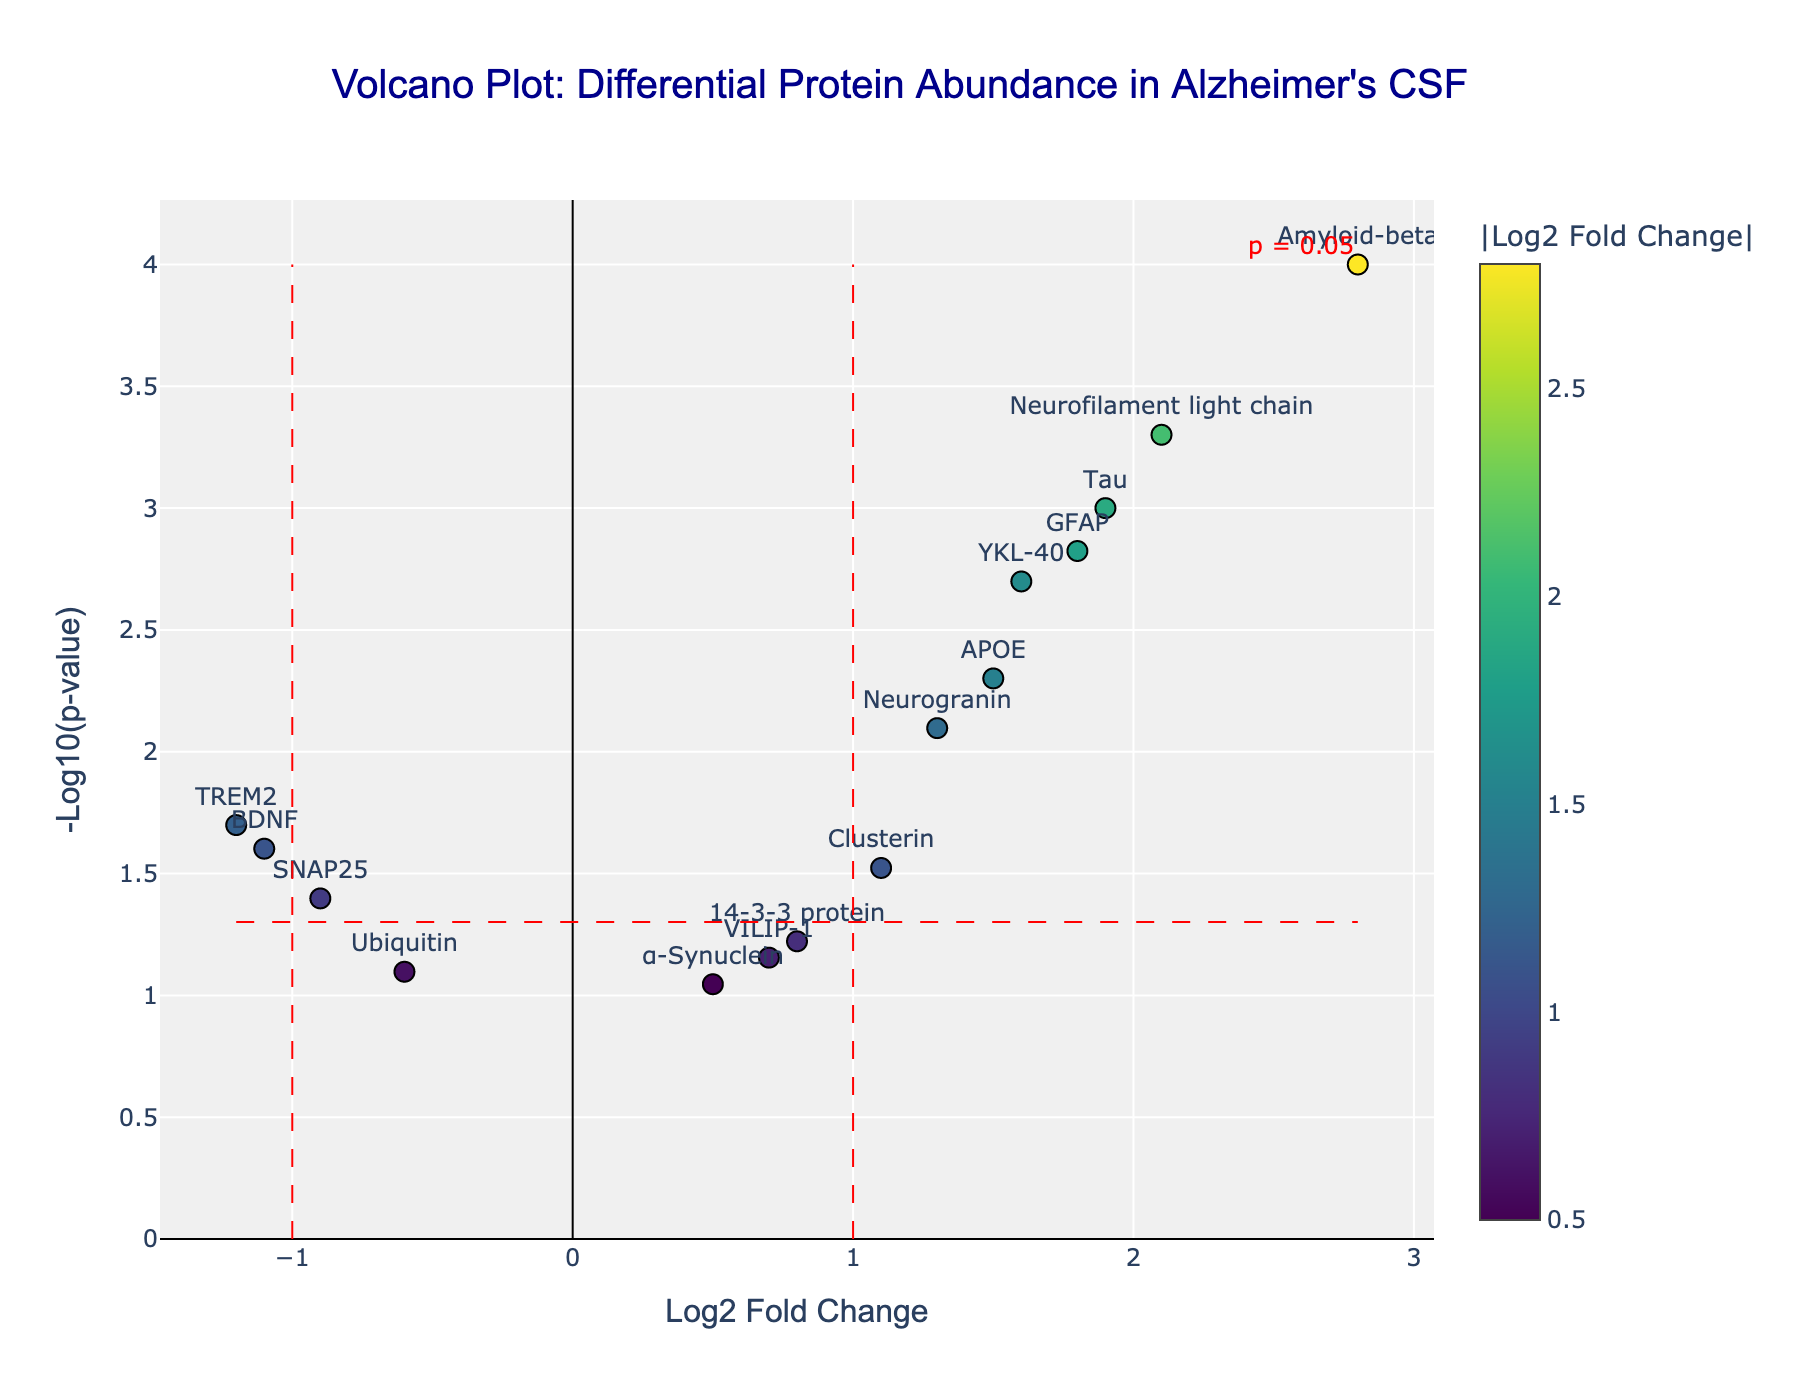What is the color of the points in the plot? The points in the plot are colored using a Viridis colorscale, which typically includes colors ranging from dark blue to yellow.
Answer: dark blue to yellow Which protein has the highest fold change in Alzheimer’s samples compared to healthy controls? Amyloid-beta has the highest fold change, with a log2 fold change of 2.8, which can be seen as the rightmost point along the x-axis.
Answer: Amyloid-beta What is the significance threshold for p-value marked on the plot? The significance threshold for the p-value is marked with a red dashed line at -log10(p-value) = 1.3, which corresponds to p = 0.05.
Answer: p = 0.05 Which protein has the smallest p-value and what is it? Amyloid-beta has the smallest p-value, which is 0.0001. This can be seen at the highest point along the y-axis.
Answer: Amyloid-beta, 0.0001 Are there any proteins with a negative fold change? If so, name one. Yes, there are proteins with a negative fold change. One example is BDNF. This can be identified by the points on the left side of the plot.
Answer: BDNF How many proteins have a log2 fold change greater than 1 and are statistically significant (p-value < 0.05)? By looking at the plot, we identify that Amyloid-beta, Tau, Neurofilament light chain, and GFAP have log2 fold changes greater than 1 and p-values less than 0.05.
Answer: 4 Which two proteins are closest to each other in terms of log2 fold change and significance? Neurogranin and Clusterin appear closest to each other in terms of both log2 fold change and significance values on the plot. Their log2 fold change values are 1.3 and 1.1, and their p-value overlaps on the y-axis.
Answer: Neurogranin and Clusterin Are there any proteins above the significance threshold line (-log10(p-value) > 1.3) that are not highly abundant (log2 fold change < 1)? Name one. Yes, VILIP-1 is above the significance threshold line but has a log2 fold change of 0.7.
Answer: VILIP-1 Which protein has a log2 fold change of approximately 1.6? By checking the plot, YKL-40 has a log2 fold change of approximately 1.6.
Answer: YKL-40 